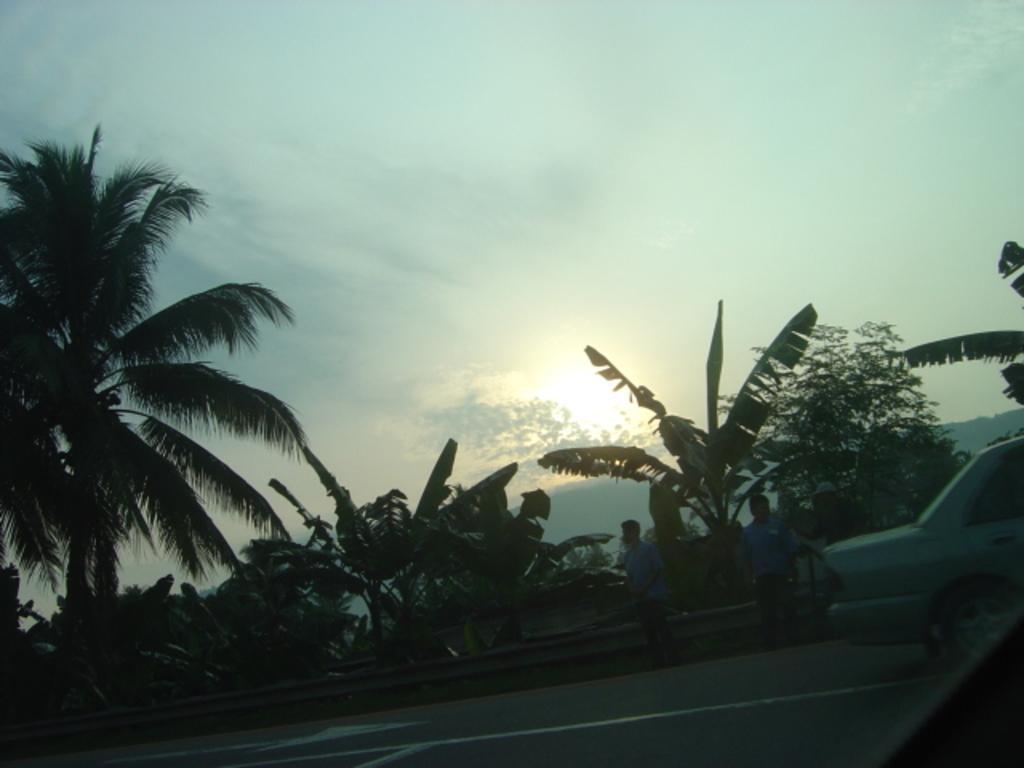Please provide a concise description of this image. In this image there is a road in the middle. On the road there are two persons. On the right side there is a car on the road. At the top there is the sky. In the background there are trees. There is a sun in the sky. 